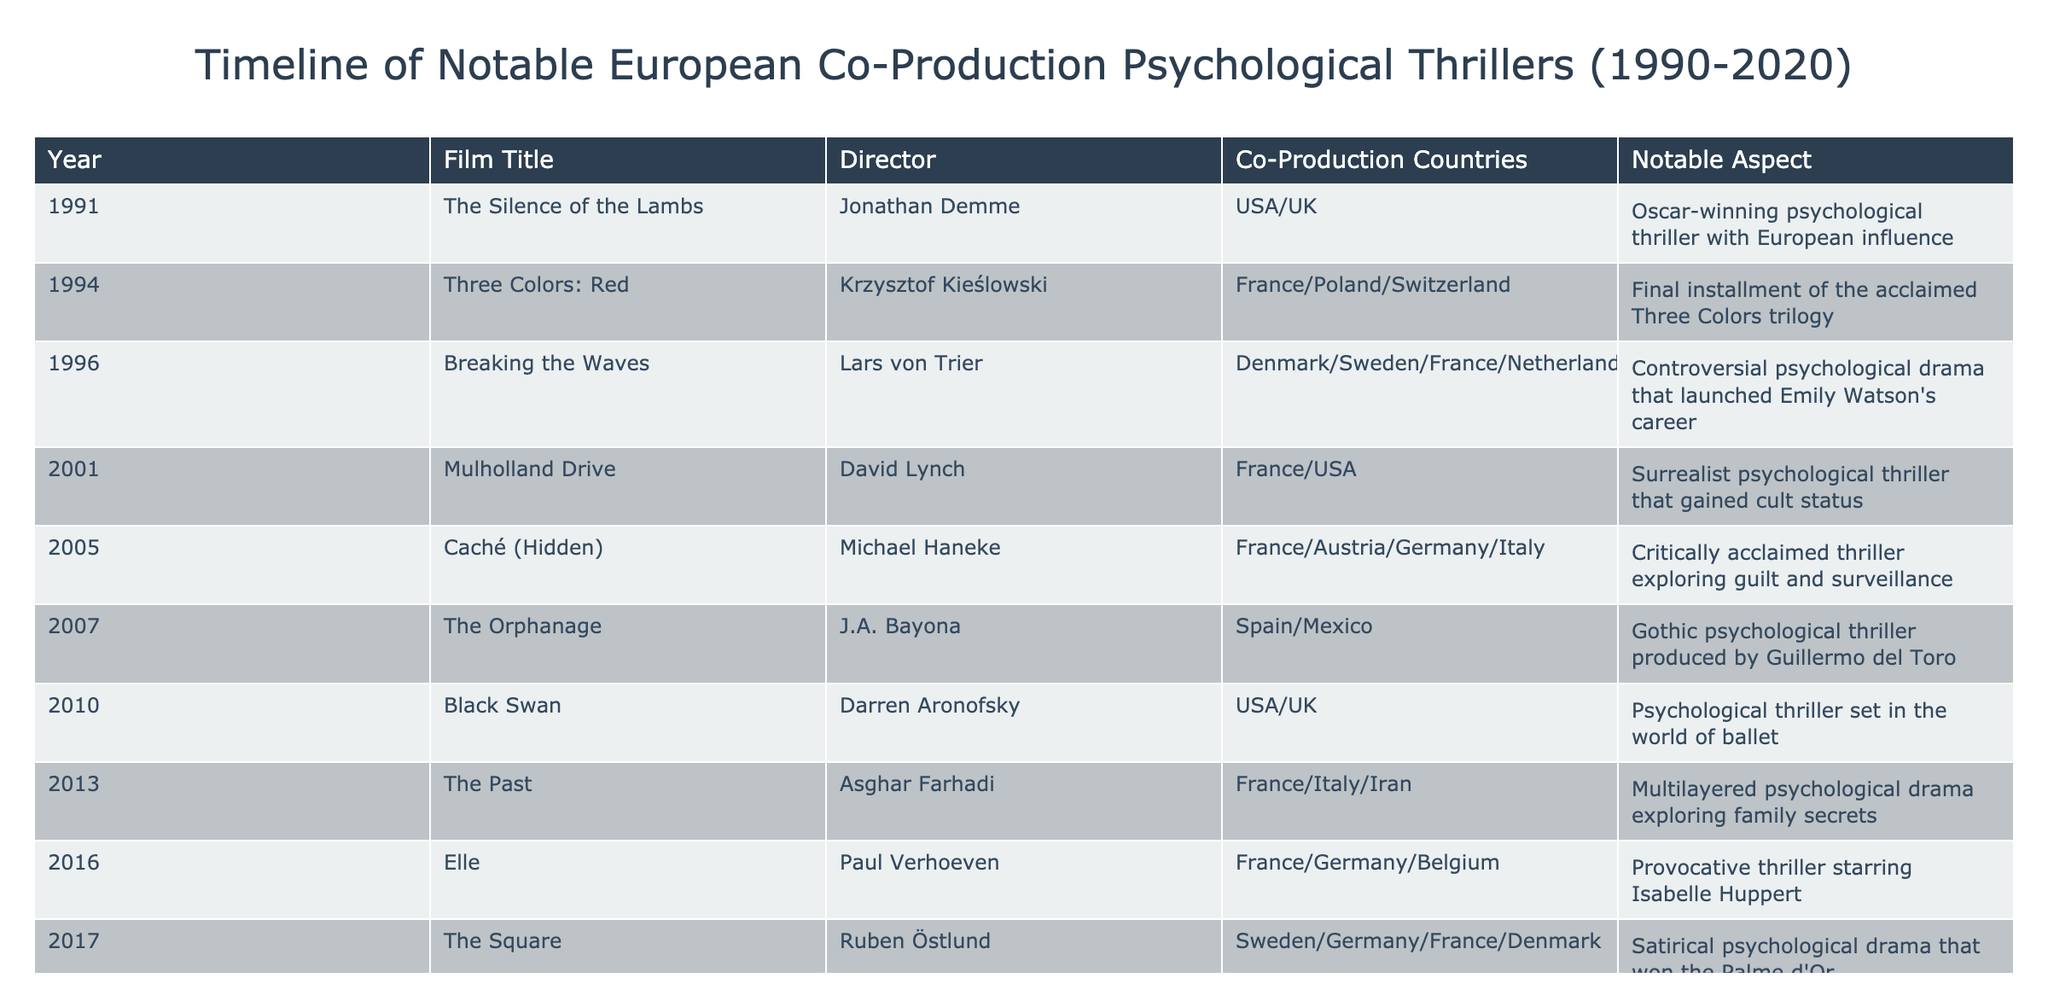What is the title of the film directed by Paul Verhoeven? The table lists all films along with their directors. By locating the row with Paul Verhoeven in the Director column, we find that the associated Film Title is "Elle".
Answer: Elle Which film from the list won the Palme d'Or? In the table, looking for notable aspects reveals that "The Square" won the Palme d'Or. It is in the row where the film title is "The Square".
Answer: The Square How many films in the table were released after 2010? To answer this, we can filter the Year column for films released after 2010. The films released after 2010 are "The Past" (2013), "Elle" (2016), and "The Square" (2017). That totals three films.
Answer: 3 Is "Caché (Hidden)" a co-production involving Germany? The table indicates that "Caché (Hidden)" is a co-production among France, Austria, Germany, and Italy. Thus, the answer is yes.
Answer: Yes What is the total number of countries represented in the co-productions for films released in the 1990s? In the table, the films from the 1990s are "The Silence of the Lambs" (USA/UK) and "Three Colors: Red" (France/Poland/Switzerland). Counting the unique countries gives us USA, UK, France, Poland, and Switzerland, totaling five different countries.
Answer: 5 Which psychological thriller directed by Lars von Trier launched Emily Watson's career? By examining the director's name in the table, the film associated with Lars von Trier is "Breaking the Waves". The table explicitly mentions that it launched Emily Watson's career.
Answer: Breaking the Waves Was "The Lighthouse" directed by a European director? The table shows "The Lighthouse" was directed by Robert Eggers. He is American, indicating that this film does not have a European director.
Answer: No Which film had the year 2005 as its release date and focused on guilt and surveillance? Analyzing the table for films released in 2005, we find "Caché (Hidden)" listed with a notable aspect focused on guilt and surveillance.
Answer: Caché (Hidden) 